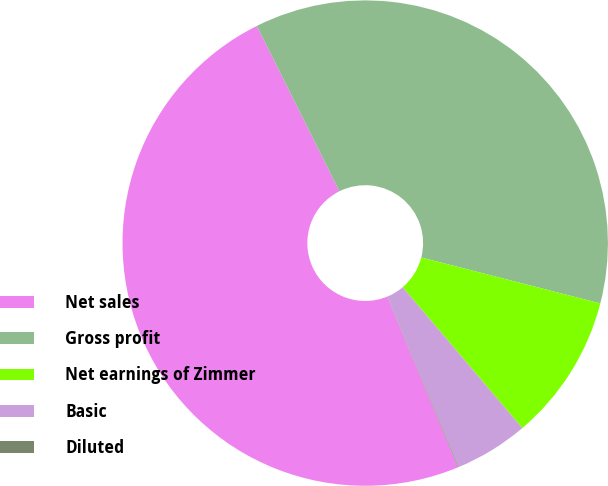Convert chart to OTSL. <chart><loc_0><loc_0><loc_500><loc_500><pie_chart><fcel>Net sales<fcel>Gross profit<fcel>Net earnings of Zimmer<fcel>Basic<fcel>Diluted<nl><fcel>48.87%<fcel>36.37%<fcel>9.8%<fcel>4.92%<fcel>0.04%<nl></chart> 